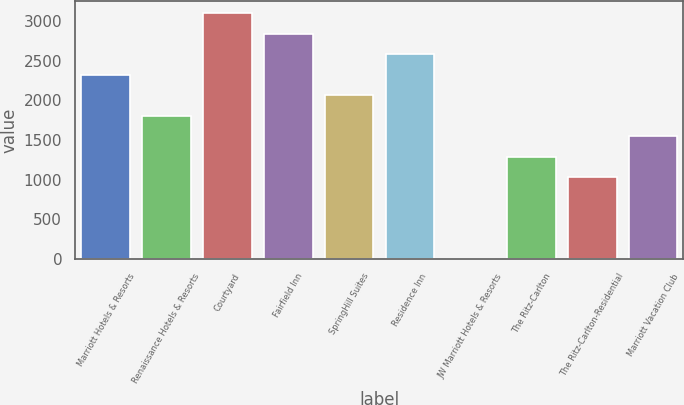Convert chart to OTSL. <chart><loc_0><loc_0><loc_500><loc_500><bar_chart><fcel>Marriott Hotels & Resorts<fcel>Renaissance Hotels & Resorts<fcel>Courtyard<fcel>Fairfield Inn<fcel>SpringHill Suites<fcel>Residence Inn<fcel>JW Marriott Hotels & Resorts<fcel>The Ritz-Carlton<fcel>The Ritz-Carlton-Residential<fcel>Marriott Vacation Club<nl><fcel>2322.1<fcel>1806.3<fcel>3095.8<fcel>2837.9<fcel>2064.2<fcel>2580<fcel>1<fcel>1290.5<fcel>1032.6<fcel>1548.4<nl></chart> 